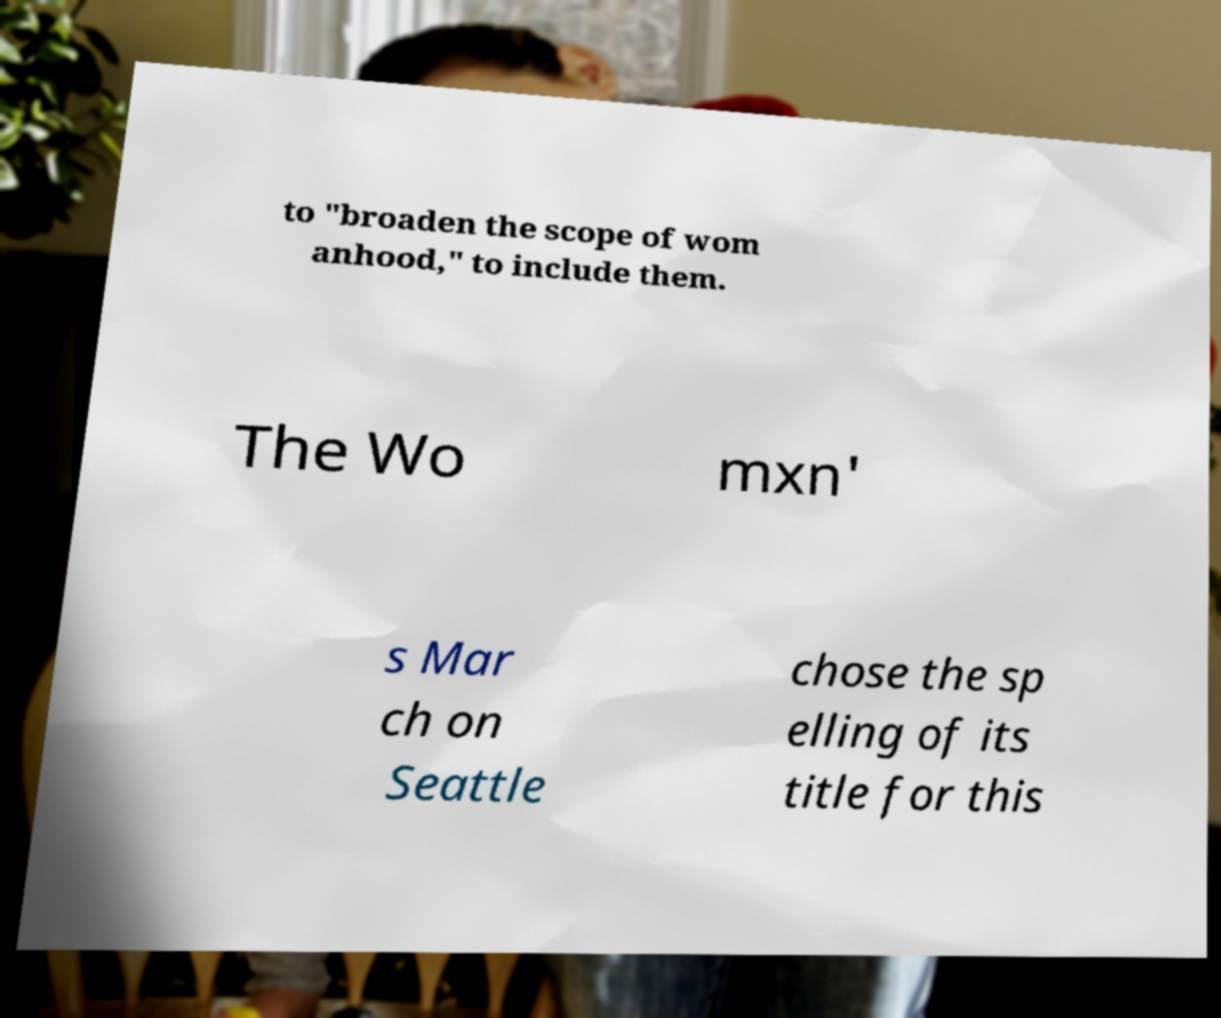I need the written content from this picture converted into text. Can you do that? to "broaden the scope of wom anhood," to include them. The Wo mxn' s Mar ch on Seattle chose the sp elling of its title for this 